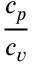<formula> <loc_0><loc_0><loc_500><loc_500>\frac { c _ { p } } { c _ { v } }</formula> 